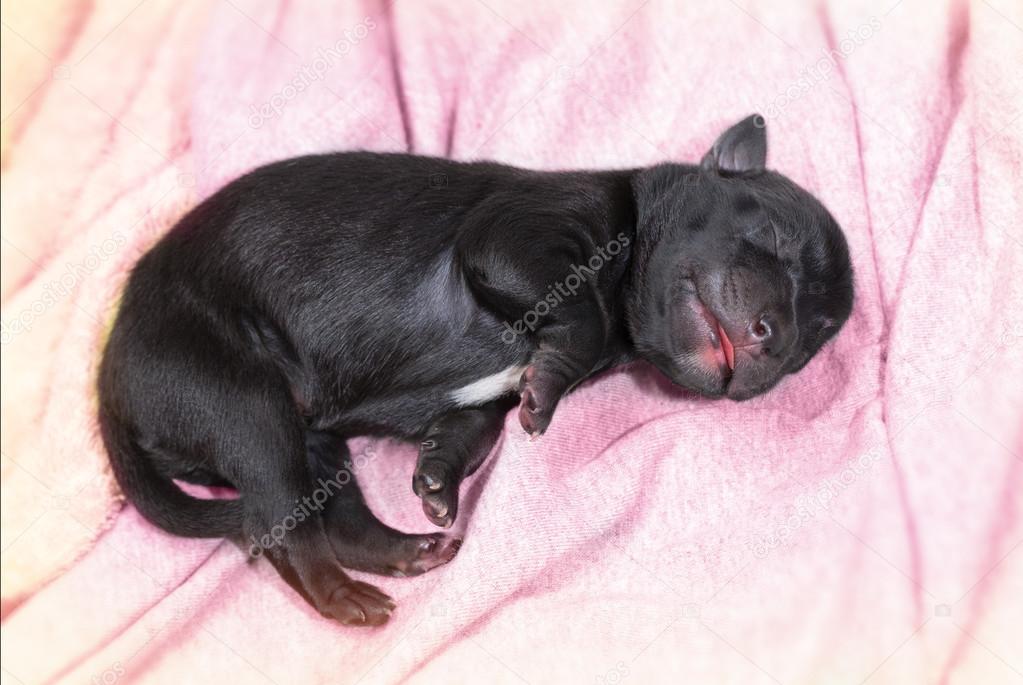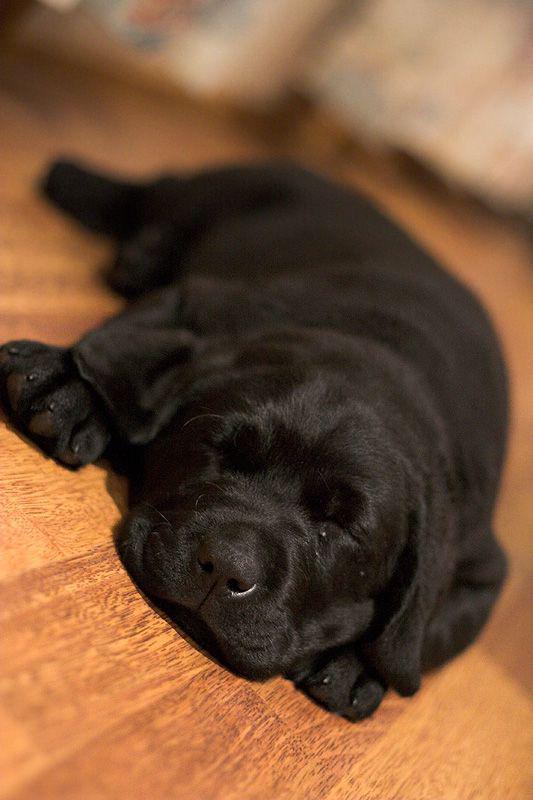The first image is the image on the left, the second image is the image on the right. Analyze the images presented: Is the assertion "A single dog is sleeping in each of the pictures." valid? Answer yes or no. Yes. 